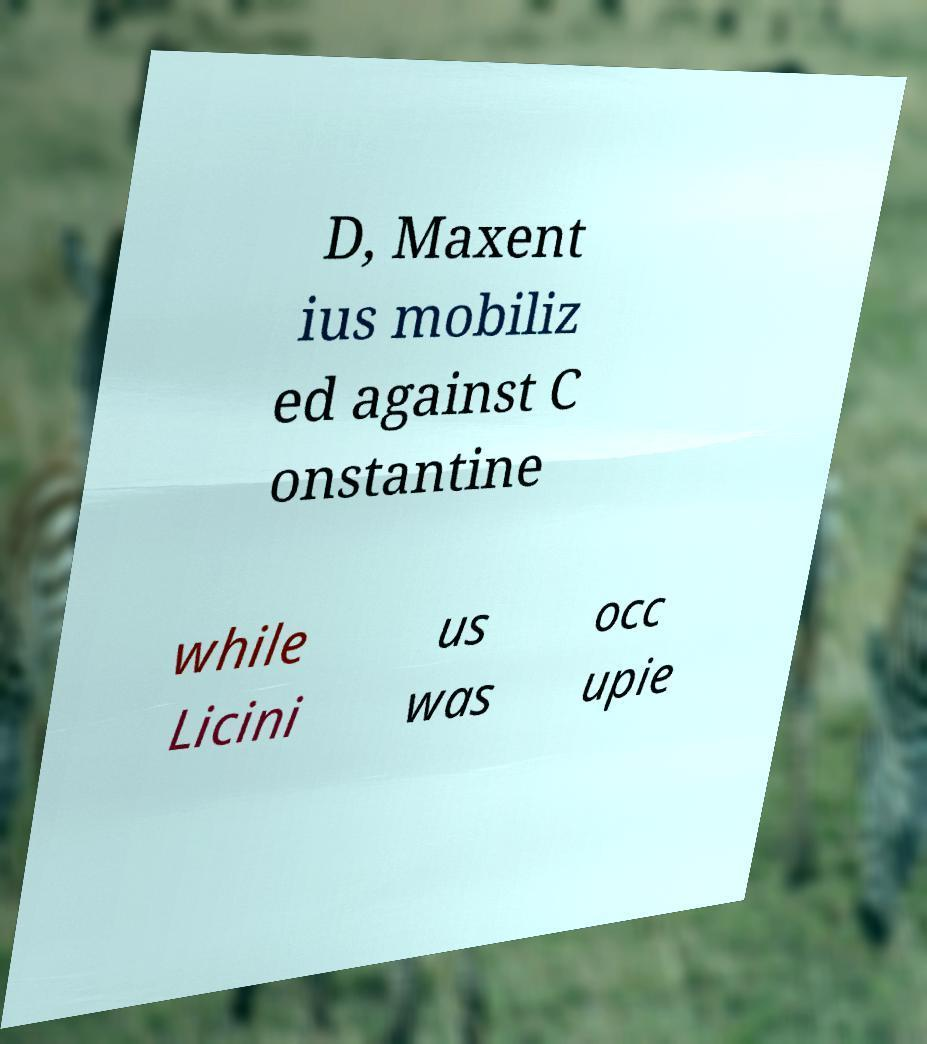Can you read and provide the text displayed in the image?This photo seems to have some interesting text. Can you extract and type it out for me? D, Maxent ius mobiliz ed against C onstantine while Licini us was occ upie 